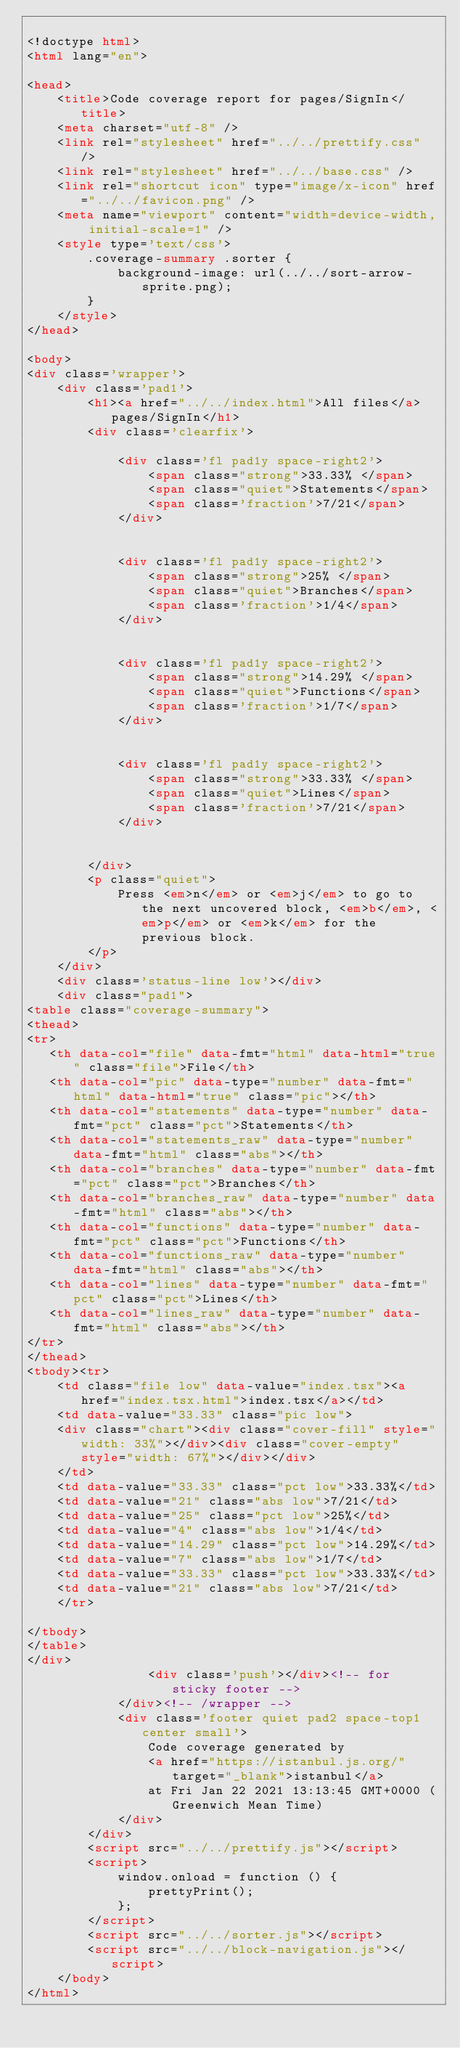<code> <loc_0><loc_0><loc_500><loc_500><_HTML_>
<!doctype html>
<html lang="en">

<head>
    <title>Code coverage report for pages/SignIn</title>
    <meta charset="utf-8" />
    <link rel="stylesheet" href="../../prettify.css" />
    <link rel="stylesheet" href="../../base.css" />
    <link rel="shortcut icon" type="image/x-icon" href="../../favicon.png" />
    <meta name="viewport" content="width=device-width, initial-scale=1" />
    <style type='text/css'>
        .coverage-summary .sorter {
            background-image: url(../../sort-arrow-sprite.png);
        }
    </style>
</head>
    
<body>
<div class='wrapper'>
    <div class='pad1'>
        <h1><a href="../../index.html">All files</a> pages/SignIn</h1>
        <div class='clearfix'>
            
            <div class='fl pad1y space-right2'>
                <span class="strong">33.33% </span>
                <span class="quiet">Statements</span>
                <span class='fraction'>7/21</span>
            </div>
        
            
            <div class='fl pad1y space-right2'>
                <span class="strong">25% </span>
                <span class="quiet">Branches</span>
                <span class='fraction'>1/4</span>
            </div>
        
            
            <div class='fl pad1y space-right2'>
                <span class="strong">14.29% </span>
                <span class="quiet">Functions</span>
                <span class='fraction'>1/7</span>
            </div>
        
            
            <div class='fl pad1y space-right2'>
                <span class="strong">33.33% </span>
                <span class="quiet">Lines</span>
                <span class='fraction'>7/21</span>
            </div>
        
            
        </div>
        <p class="quiet">
            Press <em>n</em> or <em>j</em> to go to the next uncovered block, <em>b</em>, <em>p</em> or <em>k</em> for the previous block.
        </p>
    </div>
    <div class='status-line low'></div>
    <div class="pad1">
<table class="coverage-summary">
<thead>
<tr>
   <th data-col="file" data-fmt="html" data-html="true" class="file">File</th>
   <th data-col="pic" data-type="number" data-fmt="html" data-html="true" class="pic"></th>
   <th data-col="statements" data-type="number" data-fmt="pct" class="pct">Statements</th>
   <th data-col="statements_raw" data-type="number" data-fmt="html" class="abs"></th>
   <th data-col="branches" data-type="number" data-fmt="pct" class="pct">Branches</th>
   <th data-col="branches_raw" data-type="number" data-fmt="html" class="abs"></th>
   <th data-col="functions" data-type="number" data-fmt="pct" class="pct">Functions</th>
   <th data-col="functions_raw" data-type="number" data-fmt="html" class="abs"></th>
   <th data-col="lines" data-type="number" data-fmt="pct" class="pct">Lines</th>
   <th data-col="lines_raw" data-type="number" data-fmt="html" class="abs"></th>
</tr>
</thead>
<tbody><tr>
	<td class="file low" data-value="index.tsx"><a href="index.tsx.html">index.tsx</a></td>
	<td data-value="33.33" class="pic low">
	<div class="chart"><div class="cover-fill" style="width: 33%"></div><div class="cover-empty" style="width: 67%"></div></div>
	</td>
	<td data-value="33.33" class="pct low">33.33%</td>
	<td data-value="21" class="abs low">7/21</td>
	<td data-value="25" class="pct low">25%</td>
	<td data-value="4" class="abs low">1/4</td>
	<td data-value="14.29" class="pct low">14.29%</td>
	<td data-value="7" class="abs low">1/7</td>
	<td data-value="33.33" class="pct low">33.33%</td>
	<td data-value="21" class="abs low">7/21</td>
	</tr>

</tbody>
</table>
</div>
                <div class='push'></div><!-- for sticky footer -->
            </div><!-- /wrapper -->
            <div class='footer quiet pad2 space-top1 center small'>
                Code coverage generated by
                <a href="https://istanbul.js.org/" target="_blank">istanbul</a>
                at Fri Jan 22 2021 13:13:45 GMT+0000 (Greenwich Mean Time)
            </div>
        </div>
        <script src="../../prettify.js"></script>
        <script>
            window.onload = function () {
                prettyPrint();
            };
        </script>
        <script src="../../sorter.js"></script>
        <script src="../../block-navigation.js"></script>
    </body>
</html>
    </code> 